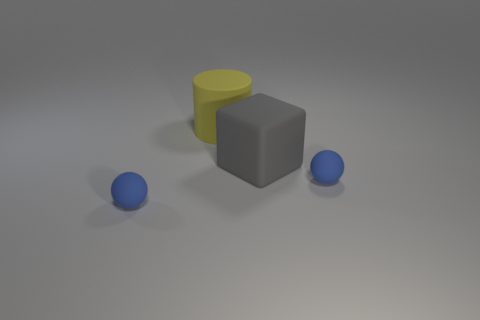What number of other yellow things have the same size as the yellow matte thing?
Offer a terse response. 0. Does the large yellow cylinder have the same material as the gray thing to the right of the yellow cylinder?
Ensure brevity in your answer.  Yes. Are there fewer big red metal things than small blue rubber spheres?
Ensure brevity in your answer.  Yes. What is the shape of the large yellow object that is made of the same material as the large cube?
Your response must be concise. Cylinder. There is a small thing to the right of the small blue rubber thing to the left of the large yellow matte thing; how many big matte objects are on the left side of it?
Keep it short and to the point. 2. The object that is both in front of the yellow thing and to the left of the gray thing has what shape?
Make the answer very short. Sphere. Are there fewer objects on the right side of the large gray rubber object than green matte things?
Offer a very short reply. No. What number of small things are yellow rubber things or yellow spheres?
Give a very brief answer. 0. There is a big cylinder; what number of tiny objects are to the left of it?
Your answer should be compact. 1. How big is the object that is to the left of the big gray rubber thing and in front of the large yellow rubber object?
Provide a short and direct response. Small. 